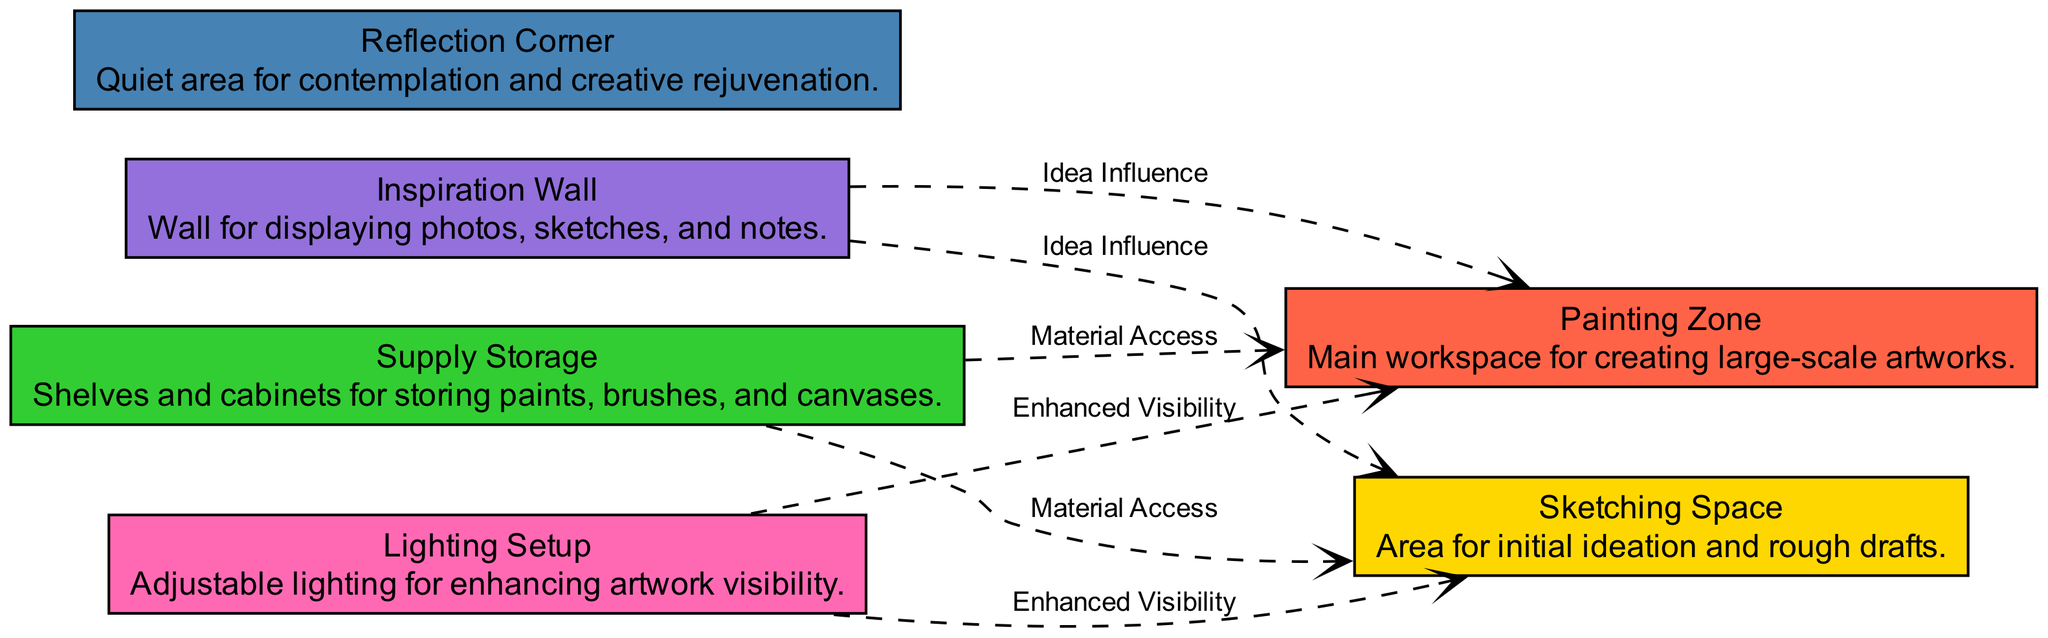What are the zones dedicated to sketching? The diagram presents a specific zone called "Sketching Space," which is a dedicated area for initial ideation and rough drafts.
Answer: Sketching Space How many zones are there in total? The diagram lists six zones, each designed for a different activity related to the studio space.
Answer: Six What does the Painting Zone provide access to? The Painting Zone directly connects to the Supply Storage, indicating that it has material access for brushes, paints, and canvases.
Answer: Material Access Which zone is labeled for contemplation? The diagram describes the "Reflection Corner" as a quiet area for contemplation and creative rejuvenation.
Answer: Reflection Corner How does the Lighting Setup support the zones? The Lighting Setup is connected to both the Sketching Space and the Painting Zone, enhancing visibility and allowing for better working conditions in both areas.
Answer: Enhanced Visibility What is the purpose of the Inspiration Wall? The Inspiration Wall serves as a space for displaying photos, sketches, and notes, which influences ideas in both the Sketching Space and the Painting Zone.
Answer: Idea Influence Which zones are connected by dashed lines to indicate relationships? Ten dashed lines connect various zones to show relationships, including connections for material access and idea influence.
Answer: Ten How many connections does the Supply Storage have? The Supply Storage has two connections: one to the Sketching Space and one to the Painting Zone, both for material access.
Answer: Two What does the Reflection Corner lack in terms of connections? The Reflection Corner does not have any outgoing connections in the diagram, indicating it functions independently without direct connections to other zones.
Answer: None 